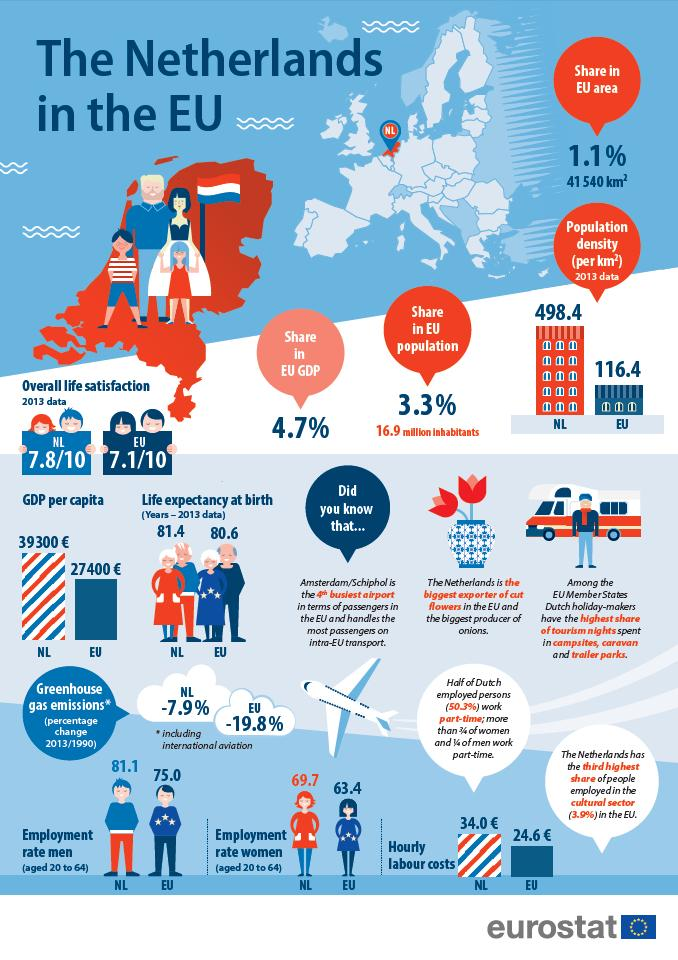Give some essential details in this illustration. The Netherlands has a higher population density than the overall population density of the European Union. The Netherlands has a higher life expectancy at birth than the overall average for the European Union. The Netherlands has a higher GDP per capita than the overall European Union. According to recent statistics, the Netherlands has a lower employability rate for men compared to the overall employability rate of the European Union. The Netherlands has a higher rate of women employability compared to the overall EU. 